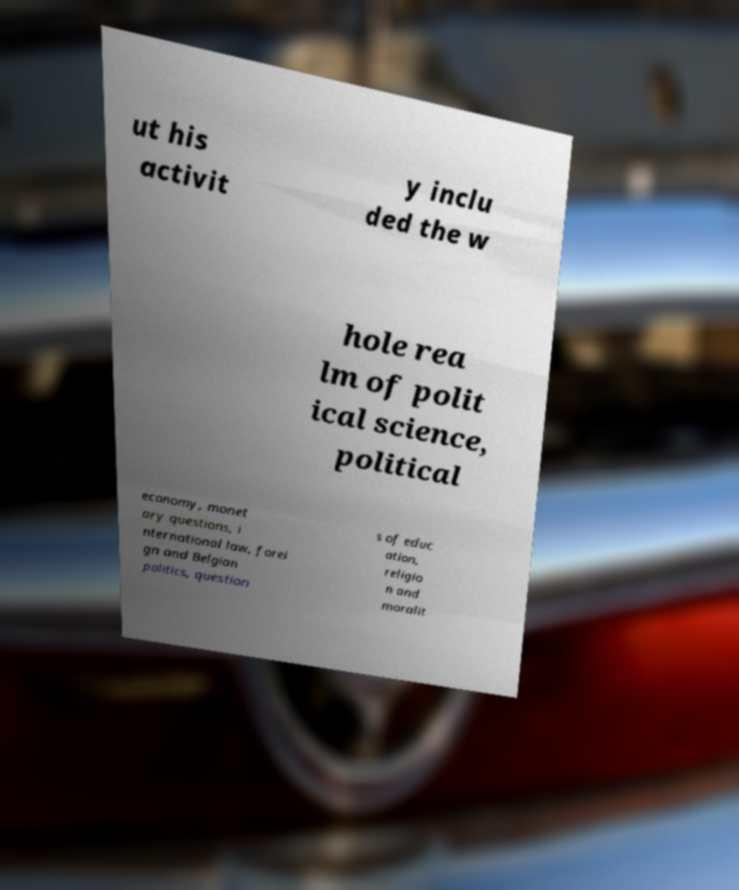For documentation purposes, I need the text within this image transcribed. Could you provide that? ut his activit y inclu ded the w hole rea lm of polit ical science, political economy, monet ary questions, i nternational law, forei gn and Belgian politics, question s of educ ation, religio n and moralit 